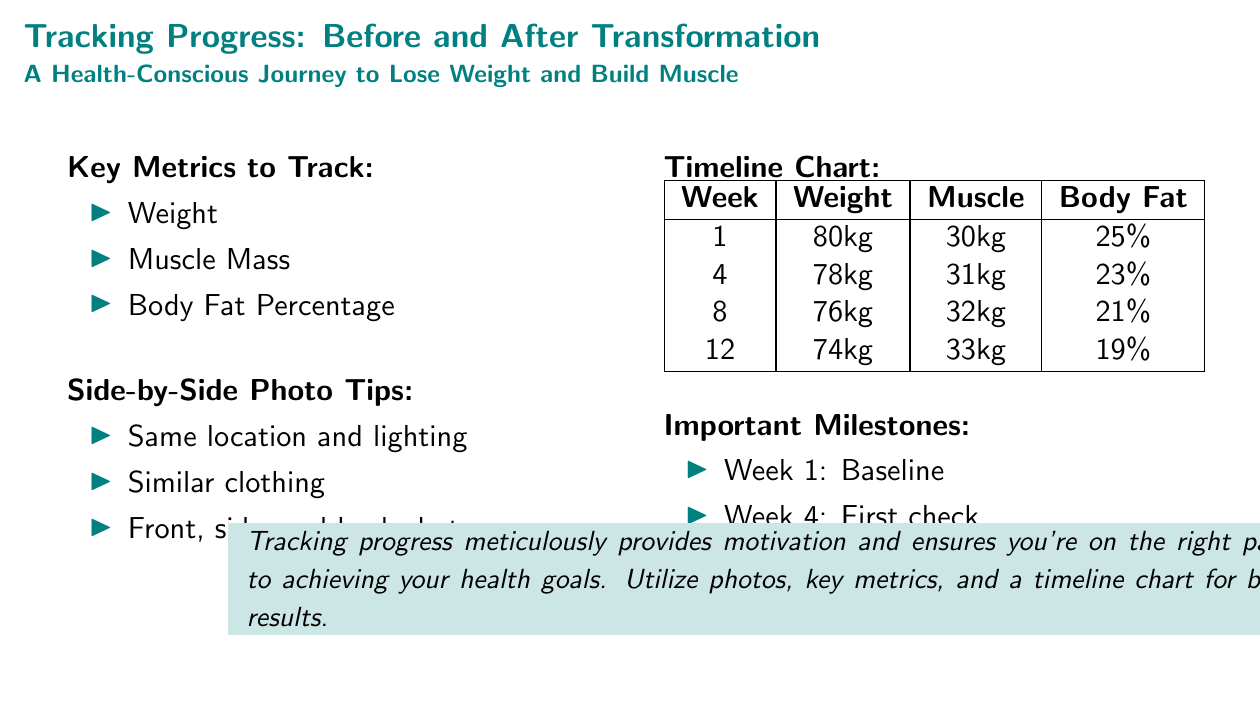what is the starting weight? The starting weight is the value listed for Week 1 in the timeline chart, which is 80kg.
Answer: 80kg what is the body fat percentage after 12 weeks? The body fat percentage after 12 weeks is found in the timeline chart for Week 12, which is 19%.
Answer: 19% how much muscle mass was gained by week 12? The gain in muscle mass from Week 1 to Week 12 can be calculated by subtracting the muscle mass at Week 1 from that at Week 12, which is 33kg - 30kg = 3kg.
Answer: 3kg what important milestone occurs in week 4? The milestone in Week 4 is marked as the first check, as stated in the Important Milestones section.
Answer: First check what are the side photo tips? The side photo tips list three criteria for effective photos documented in the Side-by-Side Photo Tips section.
Answer: Same location and lighting, similar clothing, front, side, and back shots what is the weight after week 4? The weight listed in the timeline chart for Week 4 is 78kg.
Answer: 78kg what is the percentage of body fat at week 8? The body fat percentage at Week 8 can be found in the timeline chart, which is 21%.
Answer: 21% how many kilograms of weight was lost from week 1 to week 12? The weight loss can be calculated by subtracting the weight at Week 12 from that at Week 1, which amounts to 80kg - 74kg = 6kg.
Answer: 6kg 